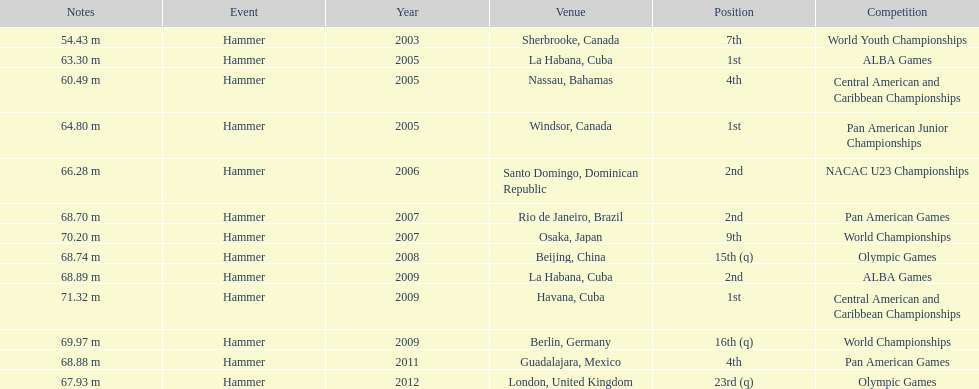What is the number of competitions held in cuba? 3. 